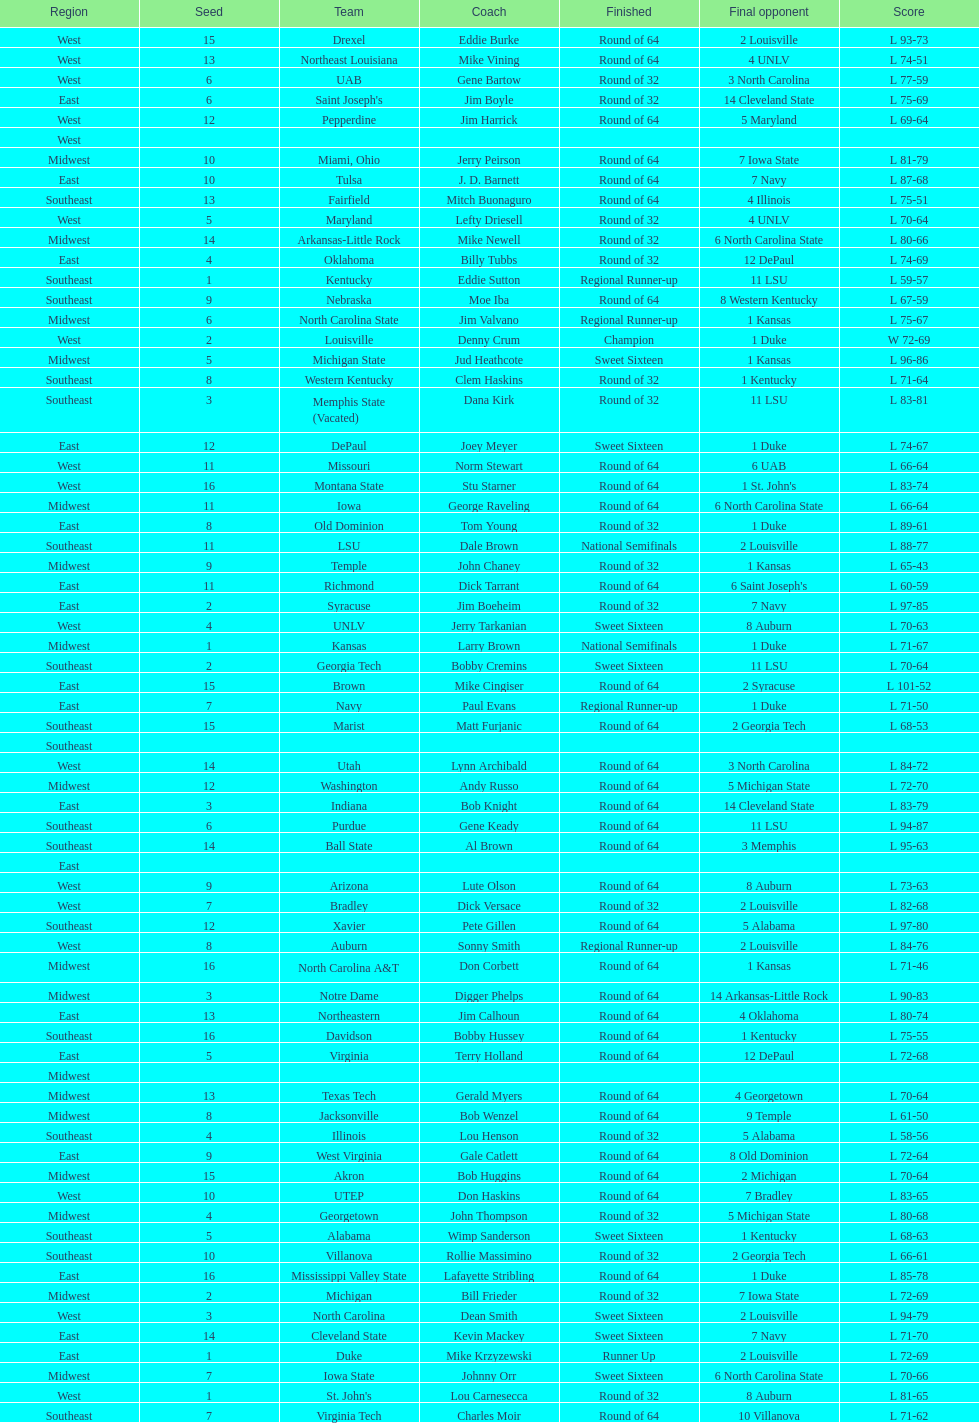What is the total count of teams that participated? 64. 